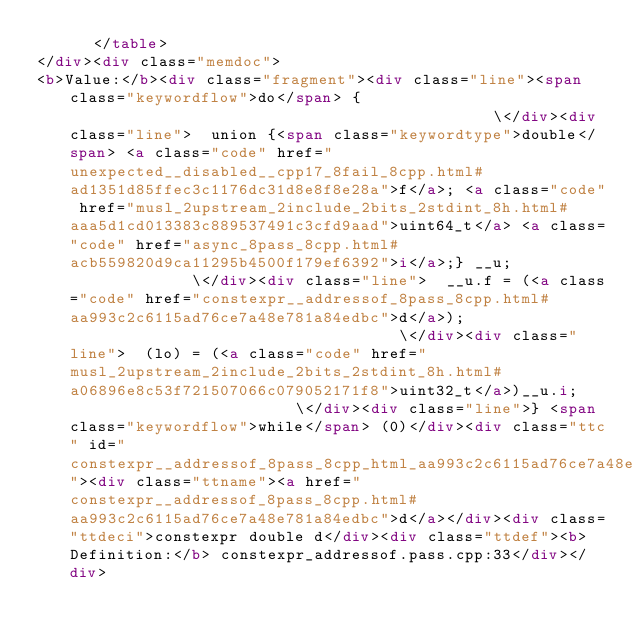<code> <loc_0><loc_0><loc_500><loc_500><_HTML_>      </table>
</div><div class="memdoc">
<b>Value:</b><div class="fragment"><div class="line"><span class="keywordflow">do</span> {                                              \</div><div class="line">  union {<span class="keywordtype">double</span> <a class="code" href="unexpected__disabled__cpp17_8fail_8cpp.html#ad1351d85ffec3c1176dc31d8e8f8e28a">f</a>; <a class="code" href="musl_2upstream_2include_2bits_2stdint_8h.html#aaa5d1cd013383c889537491c3cfd9aad">uint64_t</a> <a class="code" href="async_8pass_8cpp.html#acb559820d9ca11295b4500f179ef6392">i</a>;} __u;              \</div><div class="line">  __u.f = (<a class="code" href="constexpr__addressof_8pass_8cpp.html#aa993c2c6115ad76ce7a48e781a84edbc">d</a>);                                    \</div><div class="line">  (lo) = (<a class="code" href="musl_2upstream_2include_2bits_2stdint_8h.html#a06896e8c53f721507066c079052171f8">uint32_t</a>)__u.i;                         \</div><div class="line">} <span class="keywordflow">while</span> (0)</div><div class="ttc" id="constexpr__addressof_8pass_8cpp_html_aa993c2c6115ad76ce7a48e781a84edbc"><div class="ttname"><a href="constexpr__addressof_8pass_8cpp.html#aa993c2c6115ad76ce7a48e781a84edbc">d</a></div><div class="ttdeci">constexpr double d</div><div class="ttdef"><b>Definition:</b> constexpr_addressof.pass.cpp:33</div></div></code> 